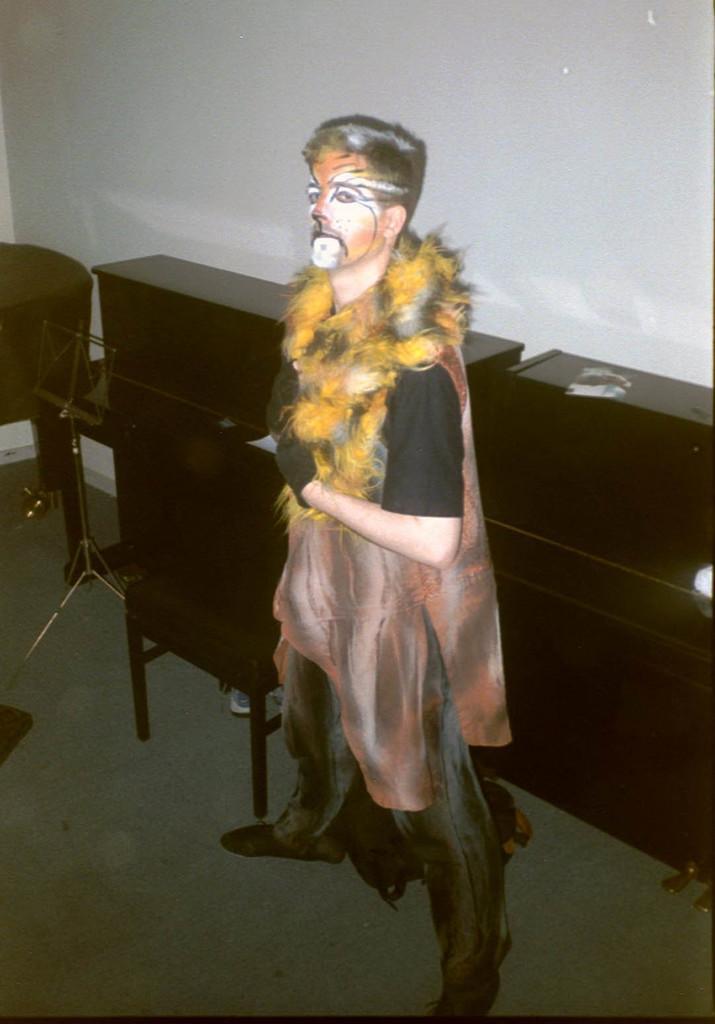Could you give a brief overview of what you see in this image? In this image I see a person who is wearing costume and I see the brown color things over here and I see the floor. In the background I see the white wall. 